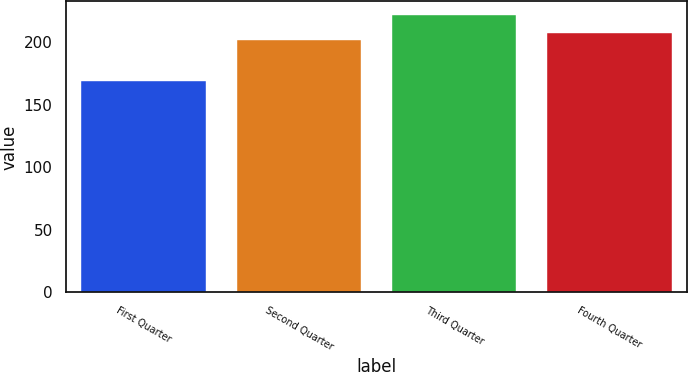Convert chart. <chart><loc_0><loc_0><loc_500><loc_500><bar_chart><fcel>First Quarter<fcel>Second Quarter<fcel>Third Quarter<fcel>Fourth Quarter<nl><fcel>169.09<fcel>202.17<fcel>221.56<fcel>207.42<nl></chart> 